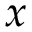<formula> <loc_0><loc_0><loc_500><loc_500>x</formula> 